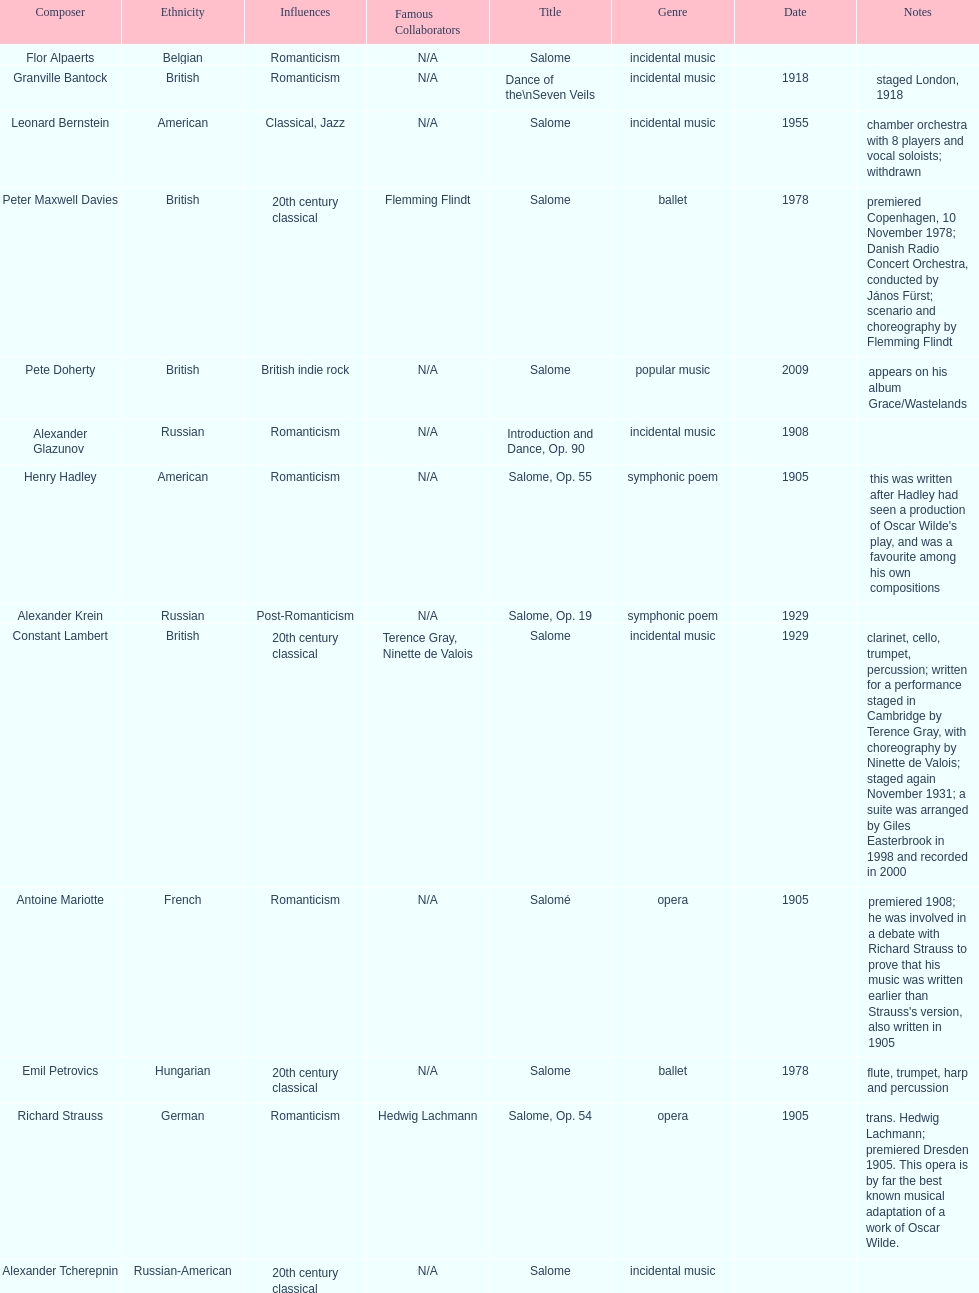Which composer produced his title after 2001? Pete Doherty. 